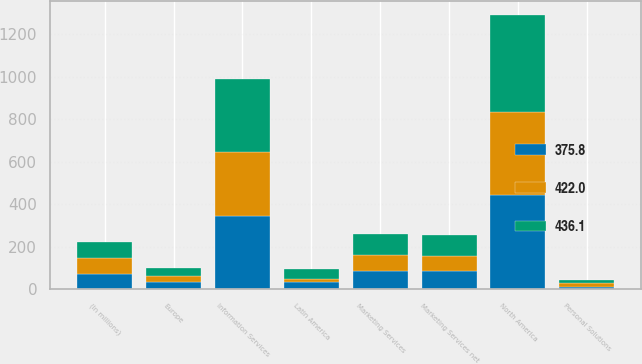Convert chart to OTSL. <chart><loc_0><loc_0><loc_500><loc_500><stacked_bar_chart><ecel><fcel>(In millions)<fcel>Information Services<fcel>Marketing Services<fcel>Marketing Services net<fcel>Personal Solutions<fcel>North America<fcel>Europe<fcel>Latin America<nl><fcel>436.1<fcel>74.4<fcel>343.3<fcel>99.1<fcel>99.1<fcel>13.6<fcel>456<fcel>35.4<fcel>45.9<nl><fcel>375.8<fcel>74.4<fcel>345.5<fcel>85.2<fcel>85.2<fcel>13.5<fcel>444.2<fcel>33.4<fcel>33.3<nl><fcel>422<fcel>74.4<fcel>299.5<fcel>74.4<fcel>72<fcel>17.6<fcel>389.1<fcel>30<fcel>17<nl></chart> 